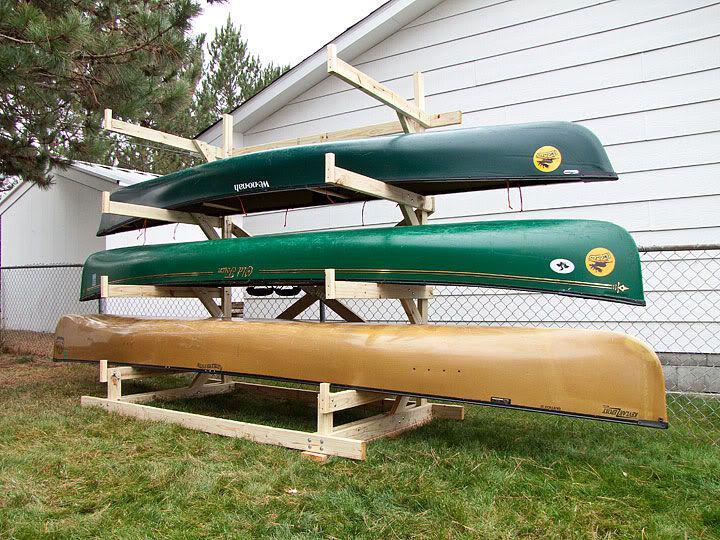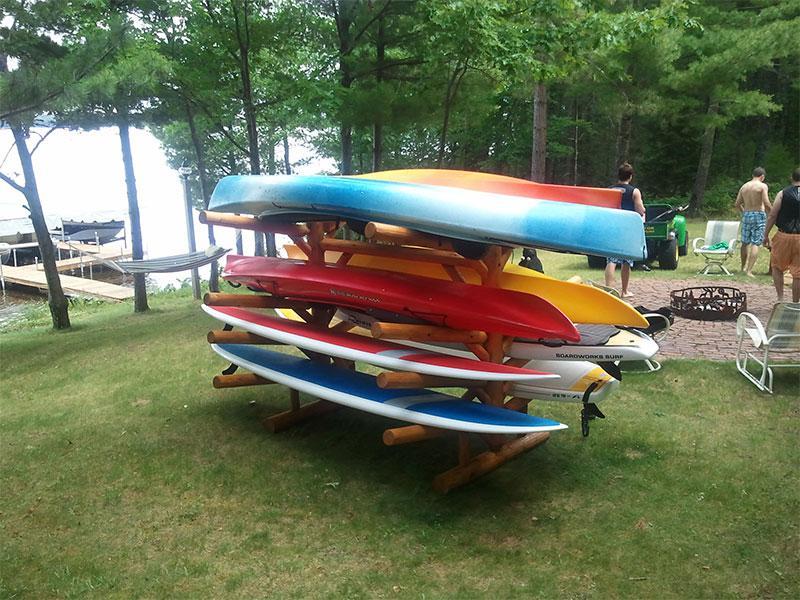The first image is the image on the left, the second image is the image on the right. Evaluate the accuracy of this statement regarding the images: "At least two of the canoes are green.". Is it true? Answer yes or no. Yes. 